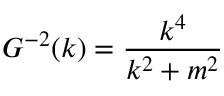<formula> <loc_0><loc_0><loc_500><loc_500>G ^ { - 2 } ( k ) = \frac { k ^ { 4 } } { k ^ { 2 } + m ^ { 2 } }</formula> 